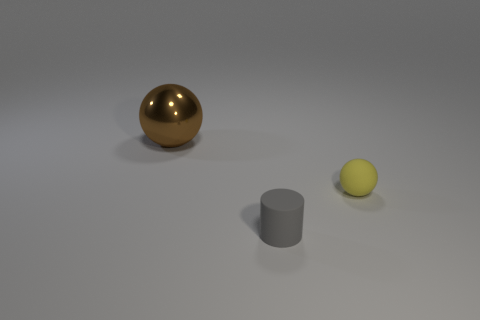There is a big brown metallic thing that is left of the small yellow sphere; does it have the same shape as the tiny yellow thing?
Make the answer very short. Yes. There is a tiny cylinder that is made of the same material as the yellow object; what is its color?
Your answer should be compact. Gray. There is a small matte thing to the left of the matte object behind the tiny matte cylinder; are there any matte objects behind it?
Ensure brevity in your answer.  Yes. What is the shape of the gray thing?
Your response must be concise. Cylinder. Is the number of rubber things in front of the gray cylinder less than the number of tiny things?
Provide a short and direct response. Yes. Is there another tiny metal thing that has the same shape as the yellow object?
Your answer should be very brief. No. The matte object that is the same size as the yellow rubber ball is what shape?
Your response must be concise. Cylinder. How many things are either yellow spheres or brown objects?
Offer a terse response. 2. Are any big red shiny cubes visible?
Make the answer very short. No. Is the number of big brown metallic spheres less than the number of large rubber cylinders?
Your response must be concise. No. 